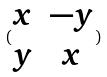<formula> <loc_0><loc_0><loc_500><loc_500>( \begin{matrix} x & - y \\ y & x \end{matrix} )</formula> 